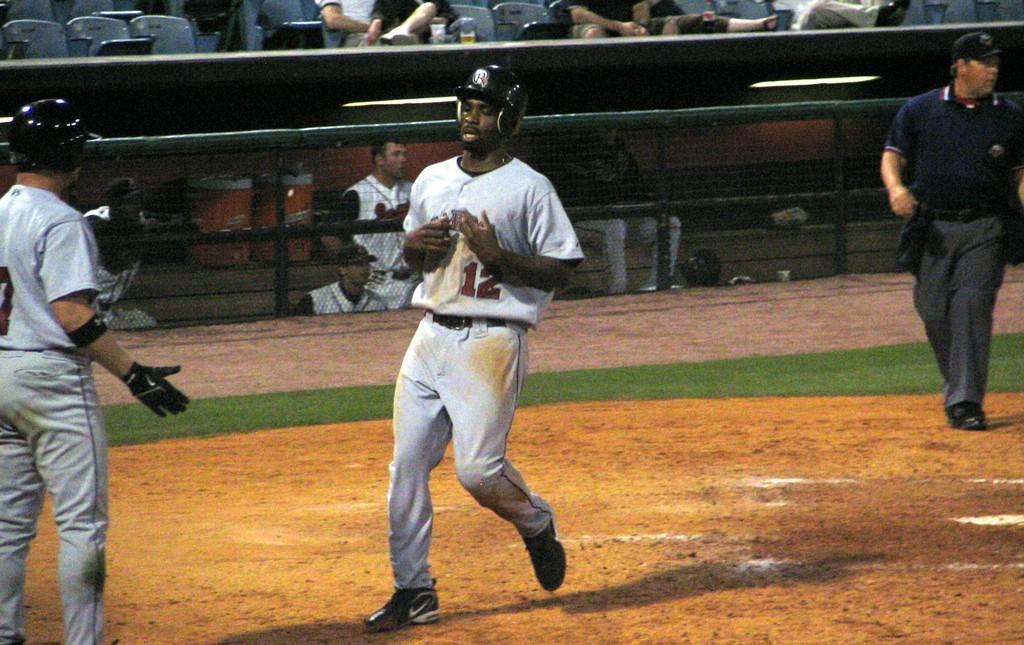Can you describe this image briefly? In this picture we can see three people on the ground, helmets, cap, fence and in the background we can see some people sitting on chairs and some objects. 